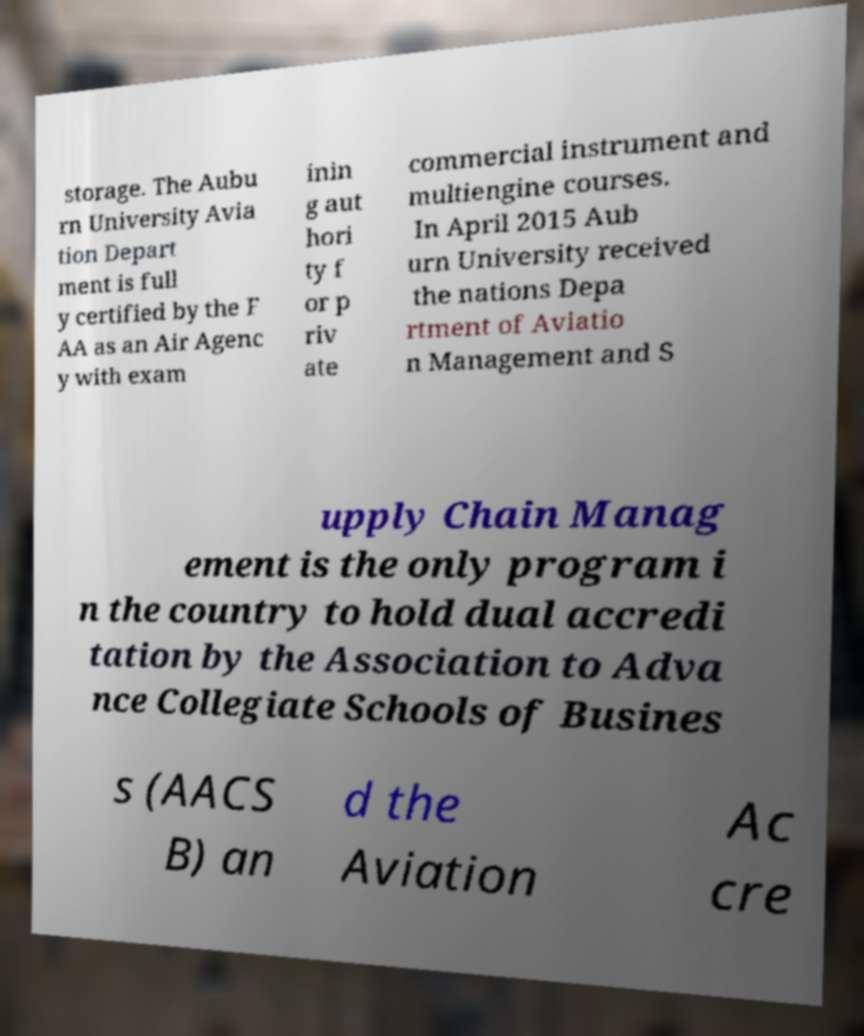Can you accurately transcribe the text from the provided image for me? storage. The Aubu rn University Avia tion Depart ment is full y certified by the F AA as an Air Agenc y with exam inin g aut hori ty f or p riv ate commercial instrument and multiengine courses. In April 2015 Aub urn University received the nations Depa rtment of Aviatio n Management and S upply Chain Manag ement is the only program i n the country to hold dual accredi tation by the Association to Adva nce Collegiate Schools of Busines s (AACS B) an d the Aviation Ac cre 